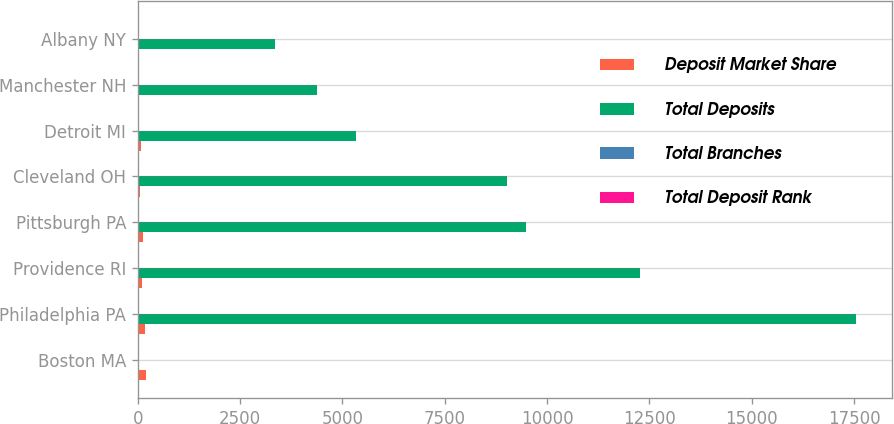Convert chart. <chart><loc_0><loc_0><loc_500><loc_500><stacked_bar_chart><ecel><fcel>Boston MA<fcel>Philadelphia PA<fcel>Providence RI<fcel>Pittsburgh PA<fcel>Cleveland OH<fcel>Detroit MI<fcel>Manchester NH<fcel>Albany NY<nl><fcel>Deposit Market Share<fcel>203<fcel>179<fcel>96<fcel>120<fcel>52<fcel>88<fcel>21<fcel>23<nl><fcel>Total Deposits<fcel>23<fcel>17548<fcel>12264<fcel>9483<fcel>9018<fcel>5335<fcel>4390<fcel>3357<nl><fcel>Total Branches<fcel>2<fcel>5<fcel>1<fcel>3<fcel>4<fcel>8<fcel>1<fcel>2<nl><fcel>Total Deposit Rank<fcel>16.1<fcel>4.8<fcel>30.2<fcel>7.3<fcel>13.5<fcel>4.1<fcel>38.6<fcel>11.4<nl></chart> 